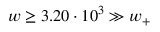Convert formula to latex. <formula><loc_0><loc_0><loc_500><loc_500>w \geq 3 . 2 0 \cdot 1 0 ^ { 3 } \gg w _ { + }</formula> 